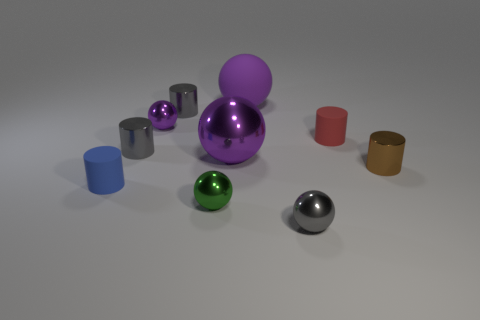Is there any pattern to how the objects are arranged? There doesn't seem to be a strict pattern to the arrangement of the objects, but there is a noticeable distribution of shapes and colors. The objects are spaced out across the surface, with no clear grouping or repeated motif that suggests a deliberate pattern. 